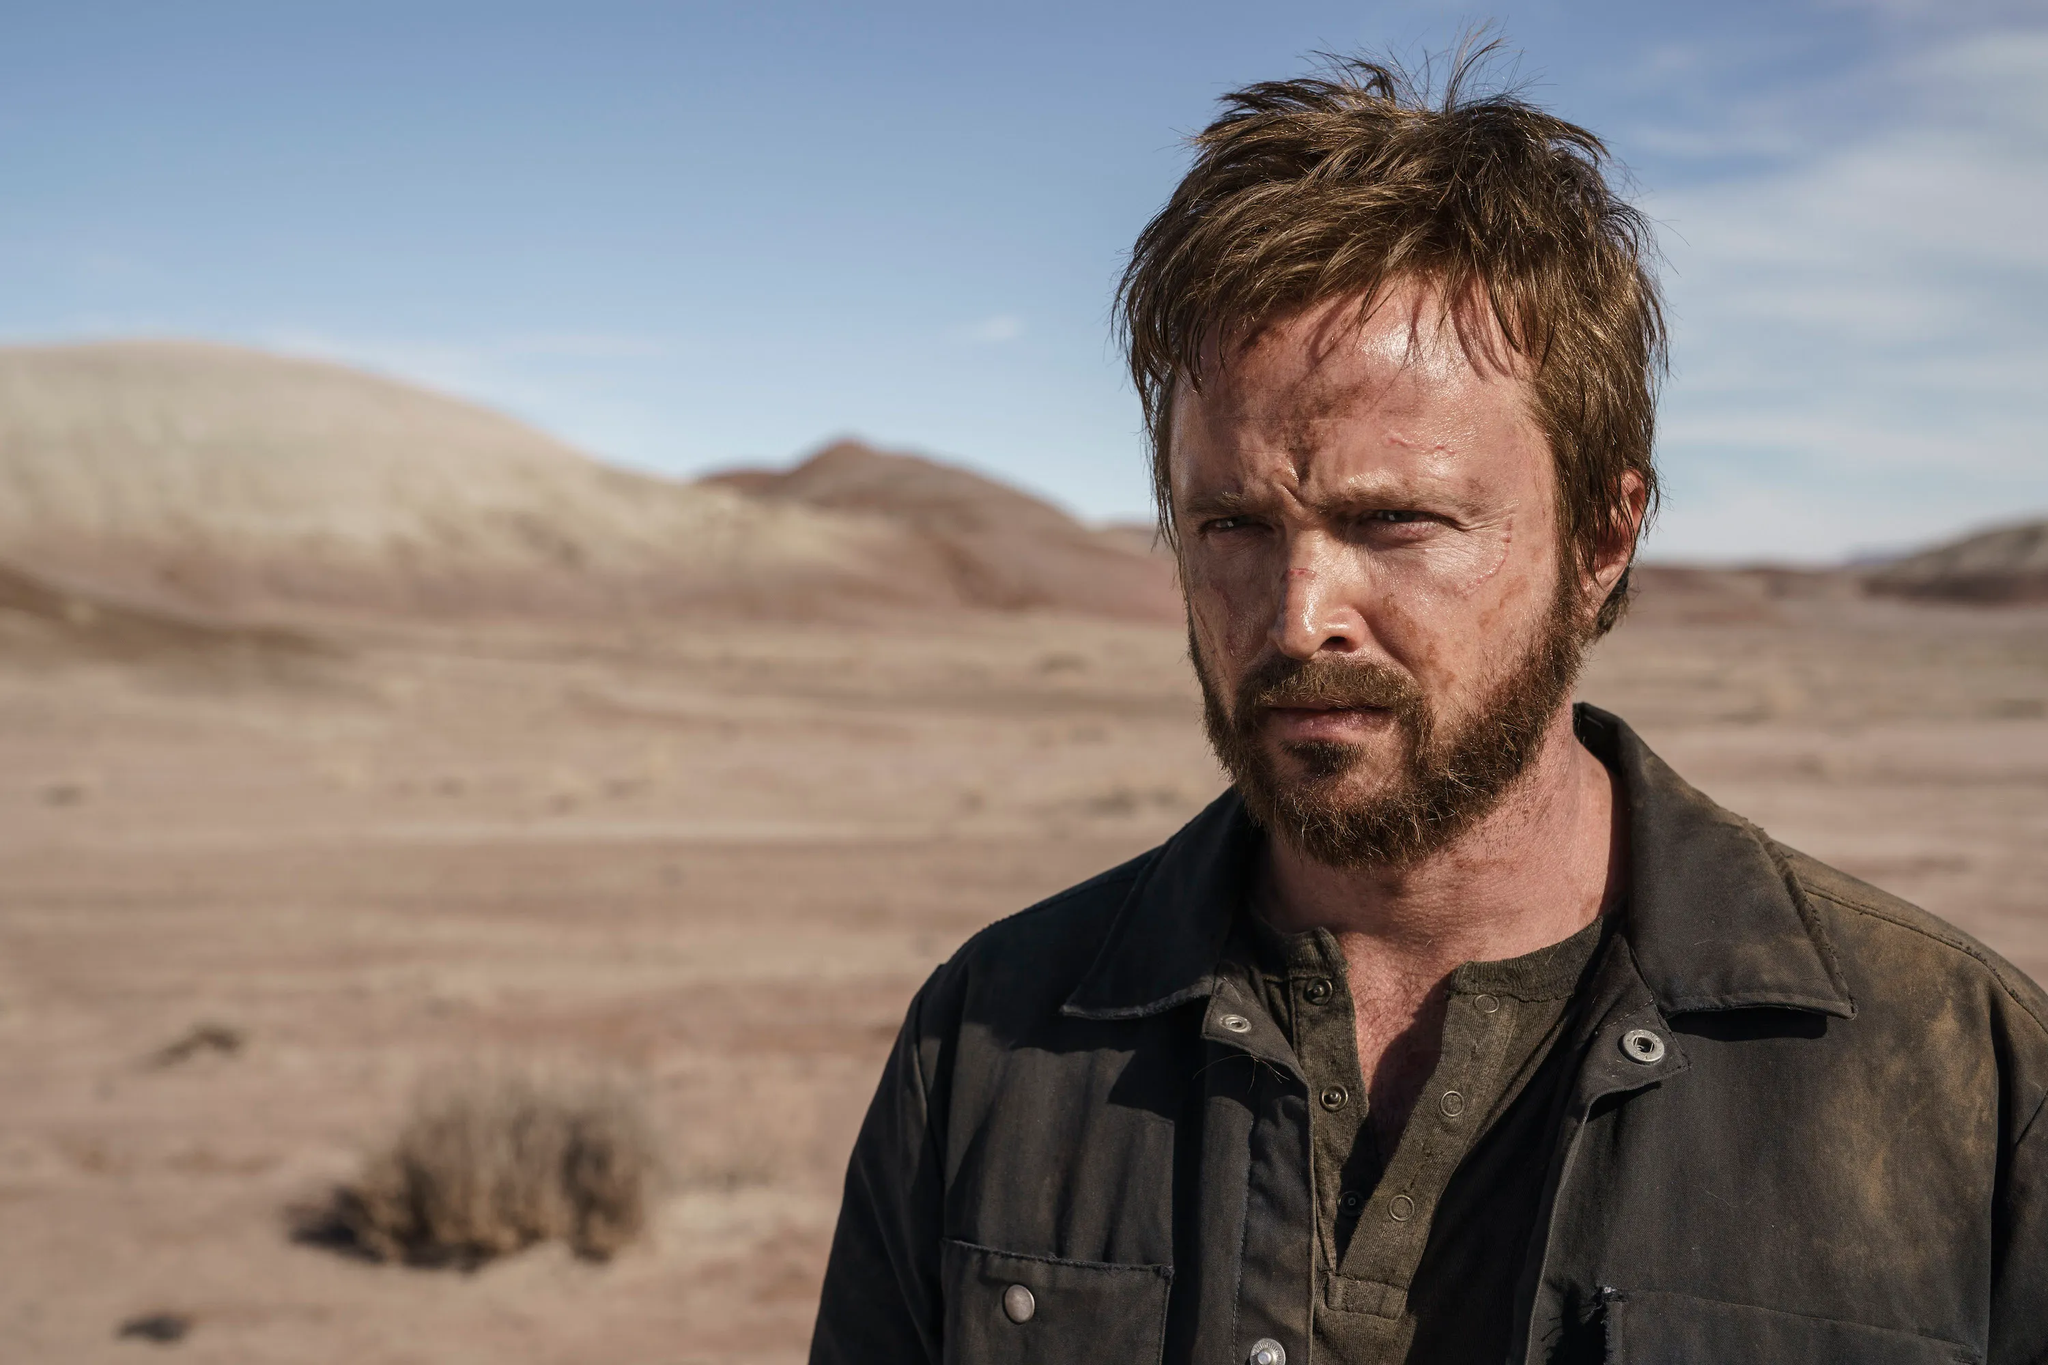Can you infer anything about the mood or theme of this image? The image conveys a mood of solitude and possible introspection. The expansive desert creates a sense of isolation, while the individual's serious expression might indicate contemplation or determination. The combination of the environment and the person's demeanor suggests themes of self-reflection, resilience, or a search for meaning within a vast and challenging landscape. 